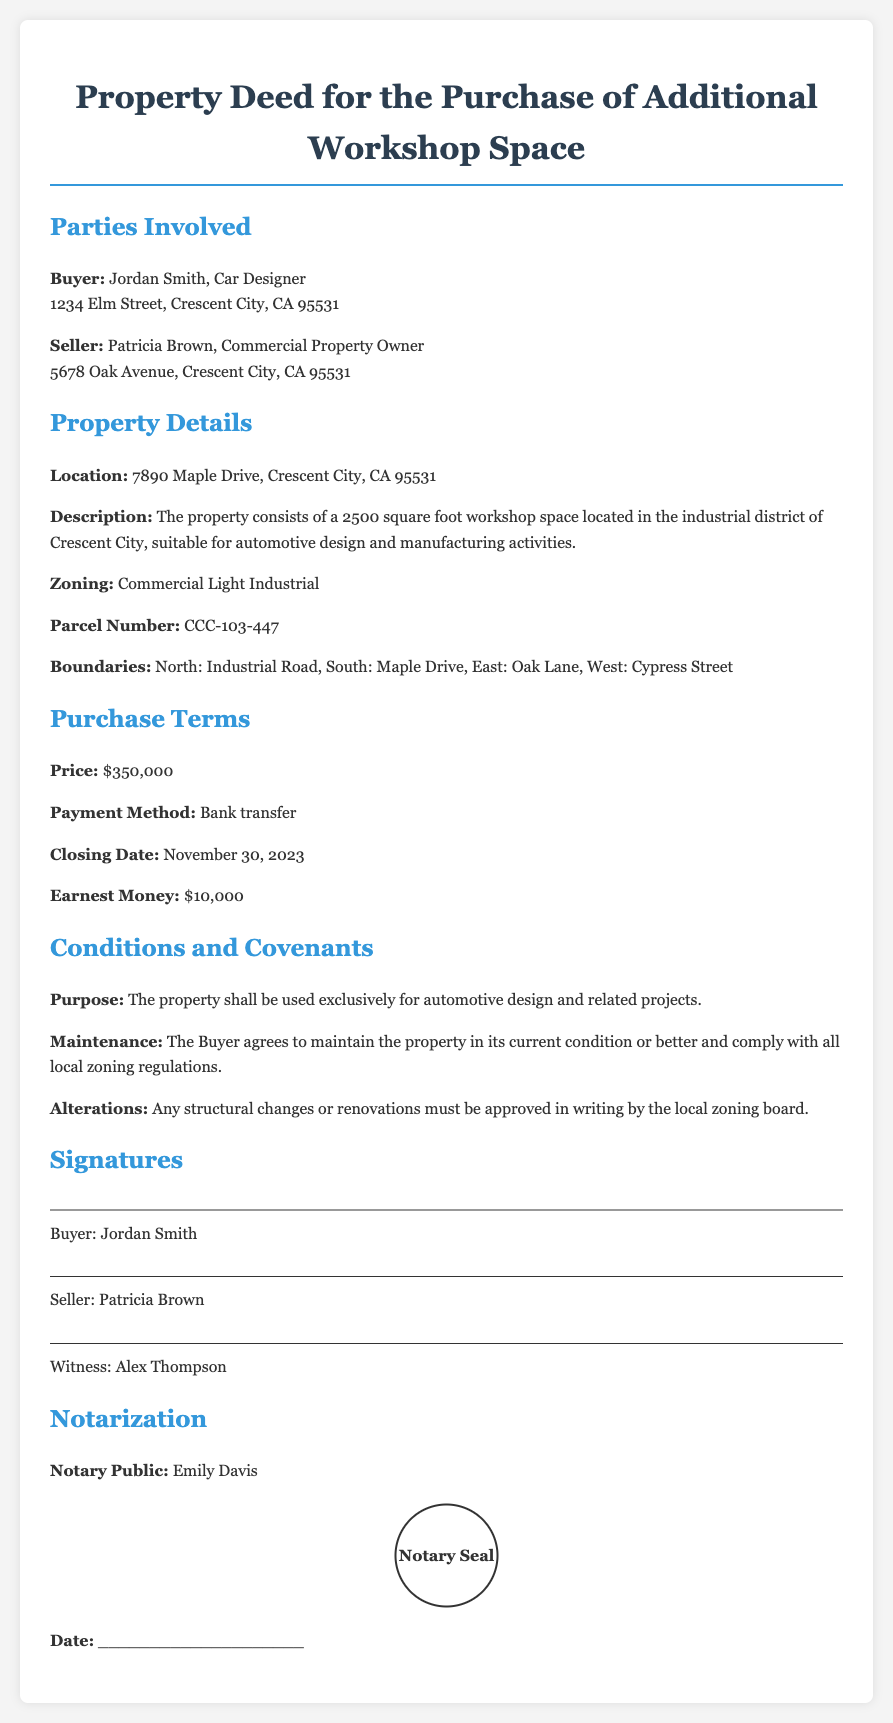What is the buyer's name? The buyer's name is specified at the beginning of the document under "Buyer."
Answer: Jordan Smith What is the property price? The price is clearly stated in the "Purchase Terms" section.
Answer: $350,000 What is the seller's address? The seller's address is listed immediately after the seller's name in the "Parties Involved" section.
Answer: 5678 Oak Avenue, Crescent City, CA 95531 What is the closing date? The closing date is mentioned in the "Purchase Terms" section.
Answer: November 30, 2023 What is the purpose of the property according to the deed? The purpose is outlined under "Conditions and Covenants."
Answer: Automotive design and related projects How much is the earnest money? The amount of earnest money is given in the "Purchase Terms" section.
Answer: $10,000 Who is the notary public? The name of the notary public is specified in the "Notarization" section.
Answer: Emily Davis What is the area of the workshop space? The area is described in the "Property Details" section.
Answer: 2500 square foot What must happen before any alterations can be made to the property? The specific condition for alterations is listed in the "Conditions and Covenants" section.
Answer: Approval by the local zoning board 